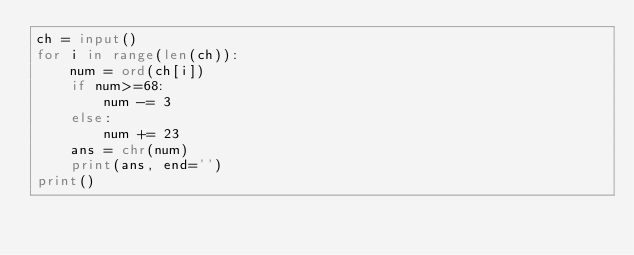<code> <loc_0><loc_0><loc_500><loc_500><_Python_>ch = input()
for i in range(len(ch)):
    num = ord(ch[i])
    if num>=68:
        num -= 3
    else:
        num += 23
    ans = chr(num)
    print(ans, end='')
print()</code> 